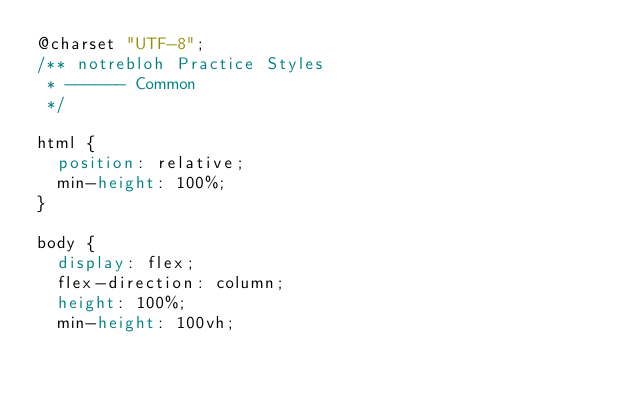Convert code to text. <code><loc_0><loc_0><loc_500><loc_500><_CSS_>@charset "UTF-8";
/** notrebloh Practice Styles
 * ------ Common
 */

html {
	position: relative;
	min-height: 100%;
}

body {
	display: flex;
	flex-direction: column;
	height: 100%;
	min-height: 100vh;</code> 